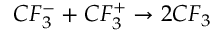Convert formula to latex. <formula><loc_0><loc_0><loc_500><loc_500>C F _ { 3 } ^ { - } + C F _ { 3 } ^ { + } \rightarrow 2 C F _ { 3 }</formula> 